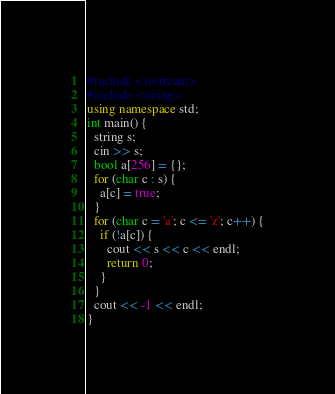Convert code to text. <code><loc_0><loc_0><loc_500><loc_500><_C++_>#include <iostream>
#include <string>
using namespace std;
int main() {
  string s;
  cin >> s;
  bool a[256] = {};
  for (char c : s) {
  	a[c] = true;
  }
  for (char c = 'a'; c <= 'z'; c++) {
    if (!a[c]) {
      cout << s << c << endl;
      return 0;
    }
  }
  cout << -1 << endl;
}</code> 